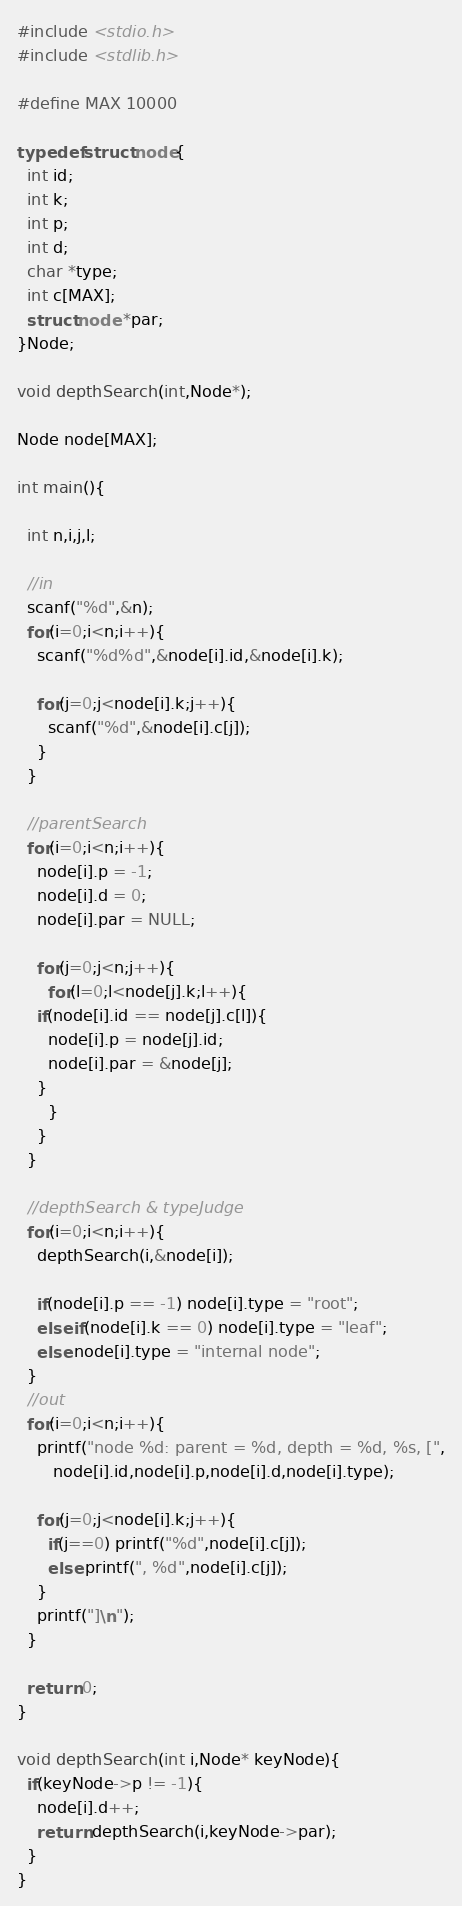<code> <loc_0><loc_0><loc_500><loc_500><_C_>#include <stdio.h>
#include <stdlib.h>

#define MAX 10000

typedef struct node{
  int id;
  int k;
  int p;
  int d;
  char *type;
  int c[MAX];
  struct node *par;
}Node;

void depthSearch(int,Node*);

Node node[MAX];

int main(){
  
  int n,i,j,l;
  
  //in
  scanf("%d",&n);
  for(i=0;i<n;i++){
    scanf("%d%d",&node[i].id,&node[i].k);
    
    for(j=0;j<node[i].k;j++){
      scanf("%d",&node[i].c[j]);
    }
  }
  
  //parentSearch
  for(i=0;i<n;i++){
    node[i].p = -1;
    node[i].d = 0;
    node[i].par = NULL;
    
    for(j=0;j<n;j++){
      for(l=0;l<node[j].k;l++){
	if(node[i].id == node[j].c[l]){
	  node[i].p = node[j].id;
	  node[i].par = &node[j];
	}
      }
    }
  }
  
  //depthSearch & typeJudge
  for(i=0;i<n;i++){
    depthSearch(i,&node[i]);
    
    if(node[i].p == -1) node[i].type = "root";
    else if(node[i].k == 0) node[i].type = "leaf";
    else node[i].type = "internal node";
  }
  //out
  for(i=0;i<n;i++){
    printf("node %d: parent = %d, depth = %d, %s, [",
	   node[i].id,node[i].p,node[i].d,node[i].type);
    
    for(j=0;j<node[i].k;j++){
      if(j==0) printf("%d",node[i].c[j]);
      else printf(", %d",node[i].c[j]);
    }
    printf("]\n");
  }

  return 0;
}

void depthSearch(int i,Node* keyNode){
  if(keyNode->p != -1){
    node[i].d++;
    return depthSearch(i,keyNode->par);
  }
}</code> 